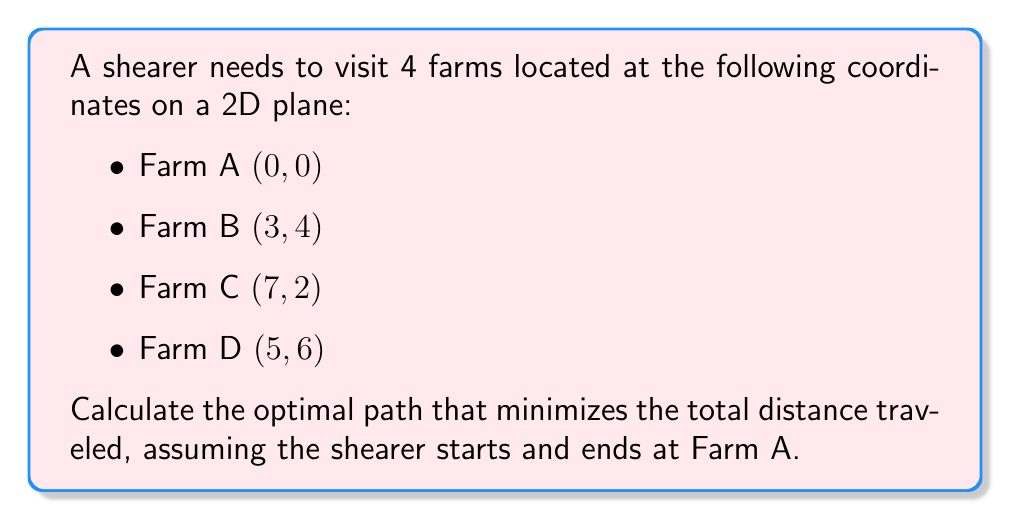Give your solution to this math problem. To solve this problem, we'll use the traveling salesman problem (TSP) approach:

1) First, calculate the distances between all pairs of farms using the Euclidean distance formula:
   $$d = \sqrt{(x_2-x_1)^2 + (y_2-y_1)^2}$$

   AB = $\sqrt{(3-0)^2 + (4-0)^2} = 5$
   AC = $\sqrt{(7-0)^2 + (2-0)^2} = \sqrt{53} \approx 7.28$
   AD = $\sqrt{(5-0)^2 + (6-0)^2} = \sqrt{61} \approx 7.81$
   BC = $\sqrt{(7-3)^2 + (2-4)^2} = \sqrt{20} \approx 4.47$
   BD = $\sqrt{(5-3)^2 + (6-4)^2} = 2\sqrt{5} \approx 4.47$
   CD = $\sqrt{(5-7)^2 + (6-2)^2} = 4\sqrt{2} \approx 5.66$

2) List all possible paths starting and ending at A:
   ABCDA, ABDCA, ACBDA, ACDBA, ADBCA, ADCBA

3) Calculate the total distance for each path:
   ABCDA: 5 + 4.47 + 5.66 + 7.81 = 22.94
   ABDCA: 5 + 4.47 + 5.66 + 7.28 = 22.41
   ACBDA: 7.28 + 4.47 + 4.47 + 7.81 = 24.03
   ACDBA: 7.28 + 5.66 + 4.47 + 5 = 22.41
   ADBCA: 7.81 + 4.47 + 4.47 + 7.28 = 24.03
   ADCBA: 7.81 + 5.66 + 4.47 + 5 = 22.94

4) The optimal path is the one with the minimum total distance. In this case, there are two paths with the minimum distance of 22.41: ABDCA and ACDBA.

[asy]
unitsize(20);
dot((0,0)); label("A", (0,0), SW);
dot((3,4)); label("B", (3,4), NE);
dot((7,2)); label("C", (7,2), SE);
dot((5,6)); label("D", (5,6), N);
draw((0,0)--(3,4)--(5,6)--(7,2)--(0,0), arrow=Arrow(TeXHead));
[/asy]
Answer: ABDCA or ACDBA, with total distance 22.41 units 